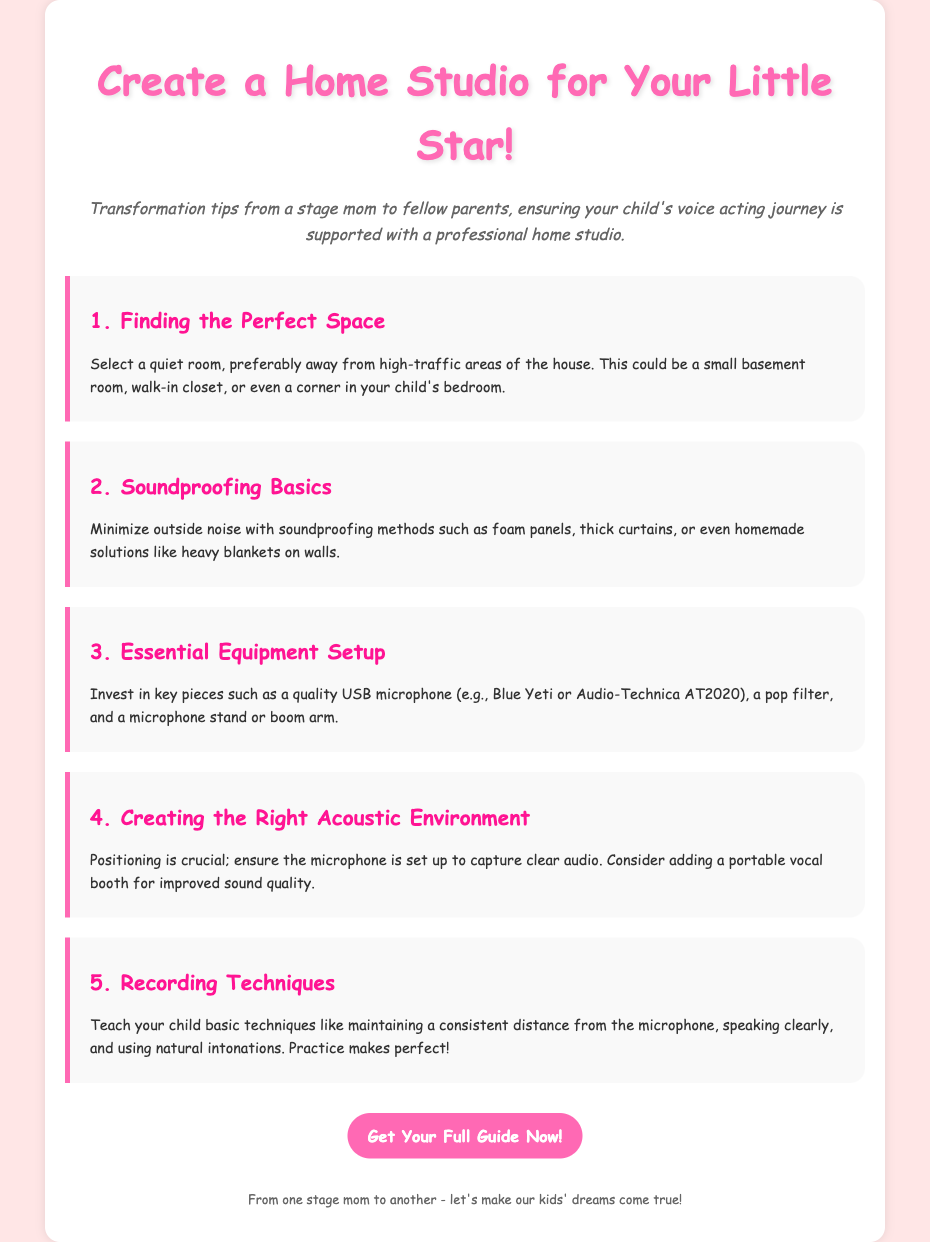What is the title of the guide? The title is clearly stated at the top of the document.
Answer: Create a Home Studio for Your Little Star! How many steps are outlined for creating a home studio? The number of sections or steps mentioned in the document can be counted.
Answer: 5 What type of microphone is recommended? The guide specifies a quality USB microphone model.
Answer: Blue Yeti or Audio-Technica AT2020 What should be done to minimize outside noise? The document provides solutions to reduce noise interference.
Answer: Soundproofing methods What is a suggested space for the home studio? The document describes ideal locations for setting up the studio.
Answer: Quiet room What should be considered for creating the right acoustic environment? It highlights necessary considerations for optimal sound capture.
Answer: Microphone positioning Who is the target audience for this guide? The introduction specifies the intended recipients of the advice given in the document.
Answer: Stage moms What is emphasized for improving recording skills? The guide offers recommendations to enhance children's recording abilities.
Answer: Practice makes perfect! 